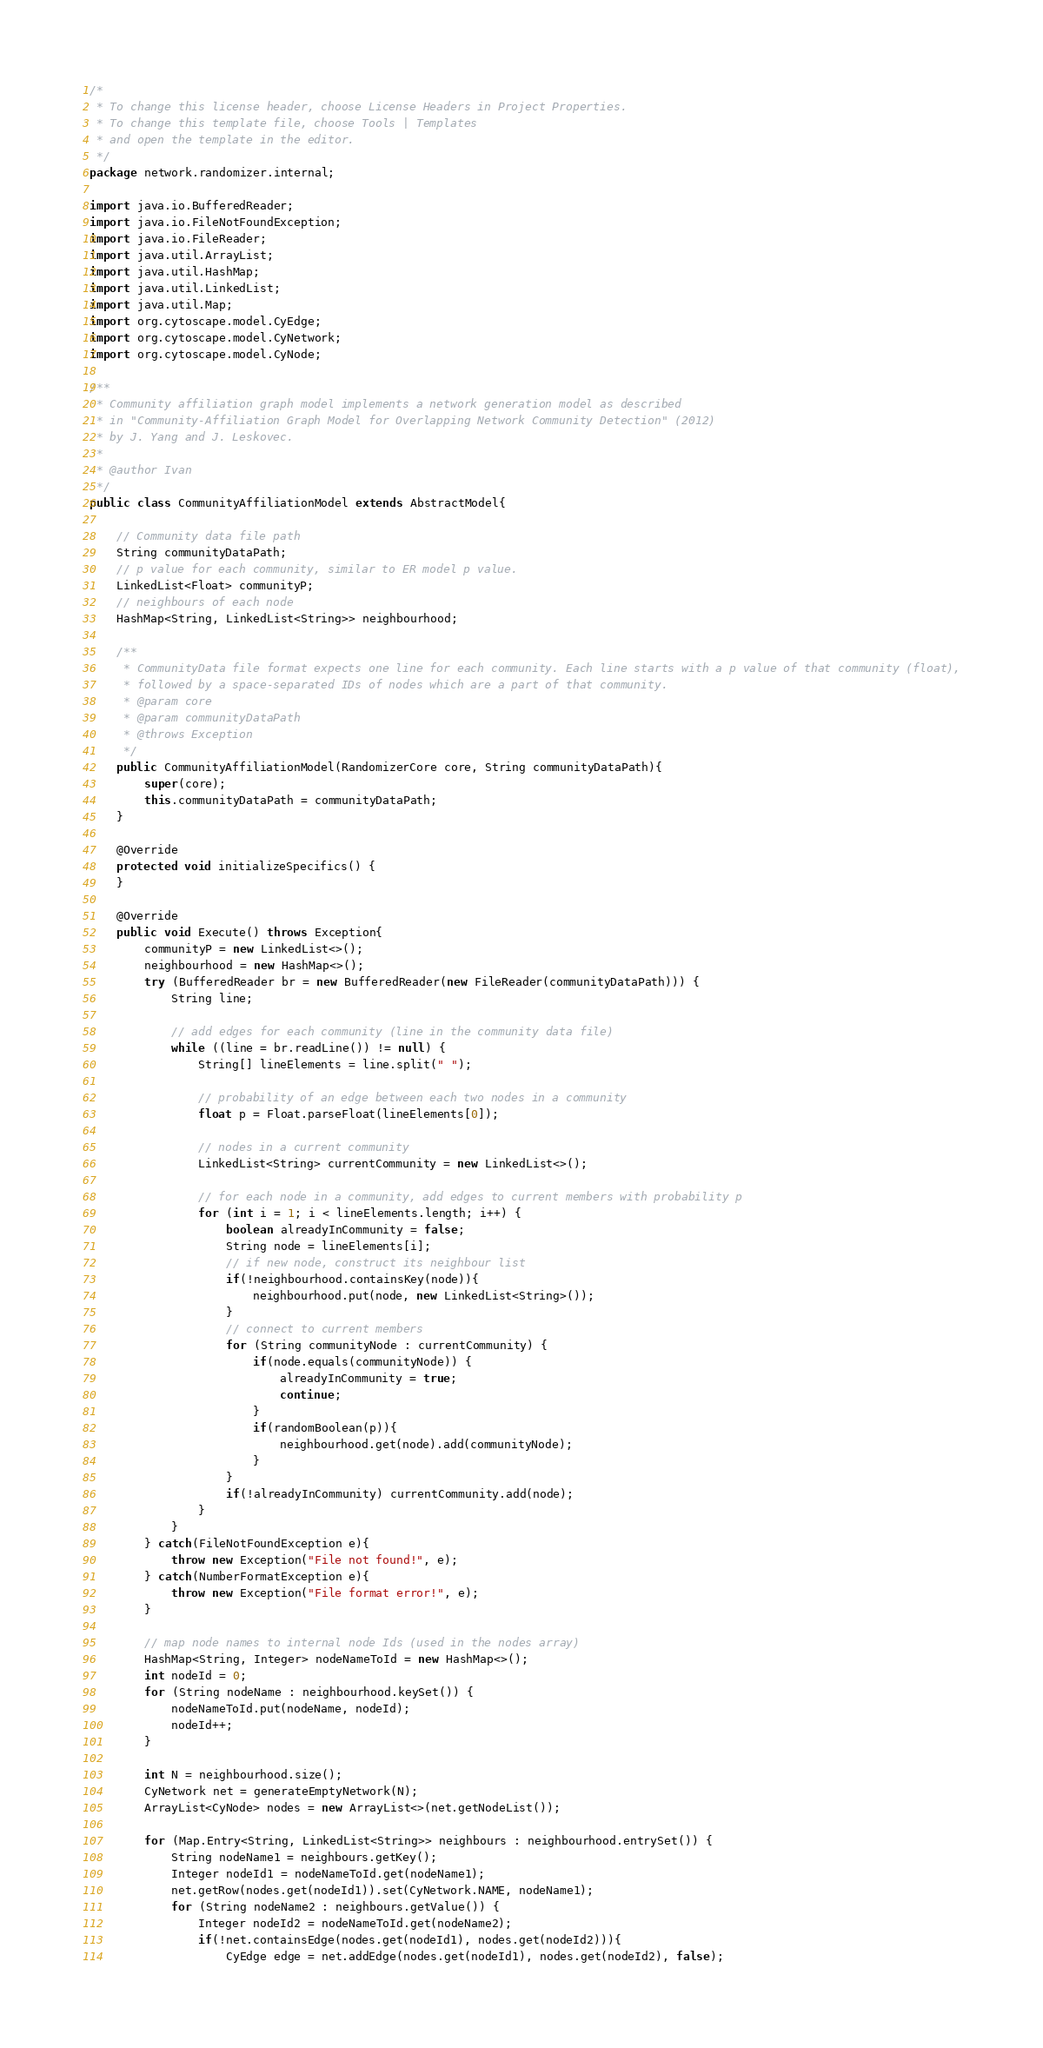Convert code to text. <code><loc_0><loc_0><loc_500><loc_500><_Java_>/*
 * To change this license header, choose License Headers in Project Properties.
 * To change this template file, choose Tools | Templates
 * and open the template in the editor.
 */
package network.randomizer.internal;

import java.io.BufferedReader;
import java.io.FileNotFoundException;
import java.io.FileReader;
import java.util.ArrayList;
import java.util.HashMap;
import java.util.LinkedList;
import java.util.Map;
import org.cytoscape.model.CyEdge;
import org.cytoscape.model.CyNetwork;
import org.cytoscape.model.CyNode;

/**
 * Community affiliation graph model implements a network generation model as described
 * in "Community-Affiliation Graph Model for Overlapping Network Community Detection" (2012)
 * by J. Yang and J. Leskovec.
 * 
 * @author Ivan
 */
public class CommunityAffiliationModel extends AbstractModel{
    
    // Community data file path
    String communityDataPath;
    // p value for each community, similar to ER model p value.
    LinkedList<Float> communityP;
    // neighbours of each node
    HashMap<String, LinkedList<String>> neighbourhood;

    /**
     * CommunityData file format expects one line for each community. Each line starts with a p value of that community (float),
     * followed by a space-separated IDs of nodes which are a part of that community.
     * @param core
     * @param communityDataPath
     * @throws Exception 
     */
    public CommunityAffiliationModel(RandomizerCore core, String communityDataPath){
        super(core);
        this.communityDataPath = communityDataPath;
    }

    @Override
    protected void initializeSpecifics() {
    }

    @Override
    public void Execute() throws Exception{
        communityP = new LinkedList<>();
        neighbourhood = new HashMap<>();
        try (BufferedReader br = new BufferedReader(new FileReader(communityDataPath))) {
            String line;
            
            // add edges for each community (line in the community data file)
            while ((line = br.readLine()) != null) {
                String[] lineElements = line.split(" ");
                
                // probability of an edge between each two nodes in a community
                float p = Float.parseFloat(lineElements[0]);
                
                // nodes in a current community
                LinkedList<String> currentCommunity = new LinkedList<>();
                
                // for each node in a community, add edges to current members with probability p
                for (int i = 1; i < lineElements.length; i++) {
                    boolean alreadyInCommunity = false;
                    String node = lineElements[i];
                    // if new node, construct its neighbour list
                    if(!neighbourhood.containsKey(node)){
                        neighbourhood.put(node, new LinkedList<String>());
                    }
                    // connect to current members
                    for (String communityNode : currentCommunity) {
                        if(node.equals(communityNode)) {
                            alreadyInCommunity = true;
                            continue;
                        }
                        if(randomBoolean(p)){
                            neighbourhood.get(node).add(communityNode);
                        }
                    }
                    if(!alreadyInCommunity) currentCommunity.add(node);
                }
            }
        } catch(FileNotFoundException e){
            throw new Exception("File not found!", e);
        } catch(NumberFormatException e){
            throw new Exception("File format error!", e);
        }

        // map node names to internal node Ids (used in the nodes array)
        HashMap<String, Integer> nodeNameToId = new HashMap<>();
        int nodeId = 0;
        for (String nodeName : neighbourhood.keySet()) {
            nodeNameToId.put(nodeName, nodeId);
            nodeId++;
        }
        
        int N = neighbourhood.size();
        CyNetwork net = generateEmptyNetwork(N);
        ArrayList<CyNode> nodes = new ArrayList<>(net.getNodeList());
        
        for (Map.Entry<String, LinkedList<String>> neighbours : neighbourhood.entrySet()) {
            String nodeName1 = neighbours.getKey();
            Integer nodeId1 = nodeNameToId.get(nodeName1);
            net.getRow(nodes.get(nodeId1)).set(CyNetwork.NAME, nodeName1);
            for (String nodeName2 : neighbours.getValue()) {
                Integer nodeId2 = nodeNameToId.get(nodeName2);
                if(!net.containsEdge(nodes.get(nodeId1), nodes.get(nodeId2))){
                    CyEdge edge = net.addEdge(nodes.get(nodeId1), nodes.get(nodeId2), false);</code> 